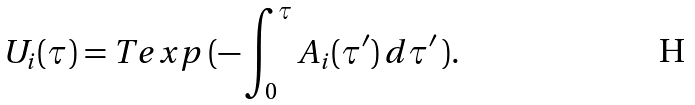<formula> <loc_0><loc_0><loc_500><loc_500>U _ { i } ( { \tau } ) = T e x p \, ( - \int _ { 0 } ^ { \tau } A _ { i } ( { \tau } ^ { \prime } ) \, d \tau ^ { \prime } \, ) .</formula> 